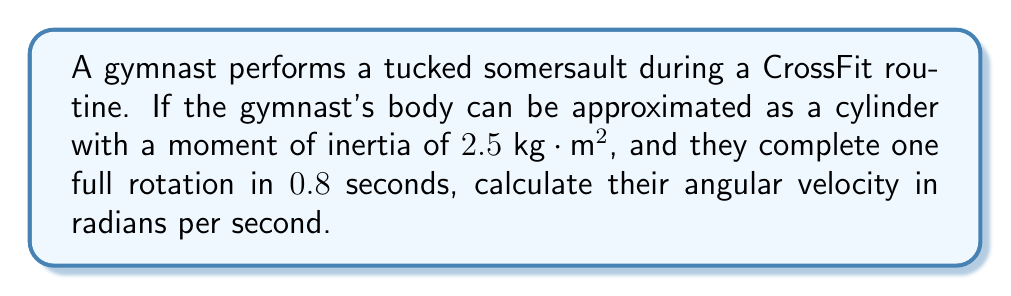Show me your answer to this math problem. To solve this problem, we'll follow these steps:

1) First, recall that angular velocity $\omega$ is defined as the rate of change of angular position with respect to time. In one full rotation, the angular displacement is $2\pi$ radians.

2) We can express angular velocity as:

   $$\omega = \frac{\Delta \theta}{\Delta t}$$

   where $\Delta \theta$ is the change in angular position and $\Delta t$ is the time taken.

3) We're given:
   - One full rotation: $\Delta \theta = 2\pi$ radians
   - Time taken: $\Delta t = 0.8$ seconds

4) Substituting these values into our equation:

   $$\omega = \frac{2\pi}{0.8}$$

5) Simplifying:

   $$\omega = \frac{2\pi}{0.8} = 2.5\pi \approx 7.85 \text{ rad/s}$$

Note: The moment of inertia given in the problem ($2.5 \text{ kg} \cdot \text{m}^2$) is not needed to calculate the angular velocity in this case. It would be useful if we were calculating torque or angular momentum.
Answer: $7.85 \text{ rad/s}$ 